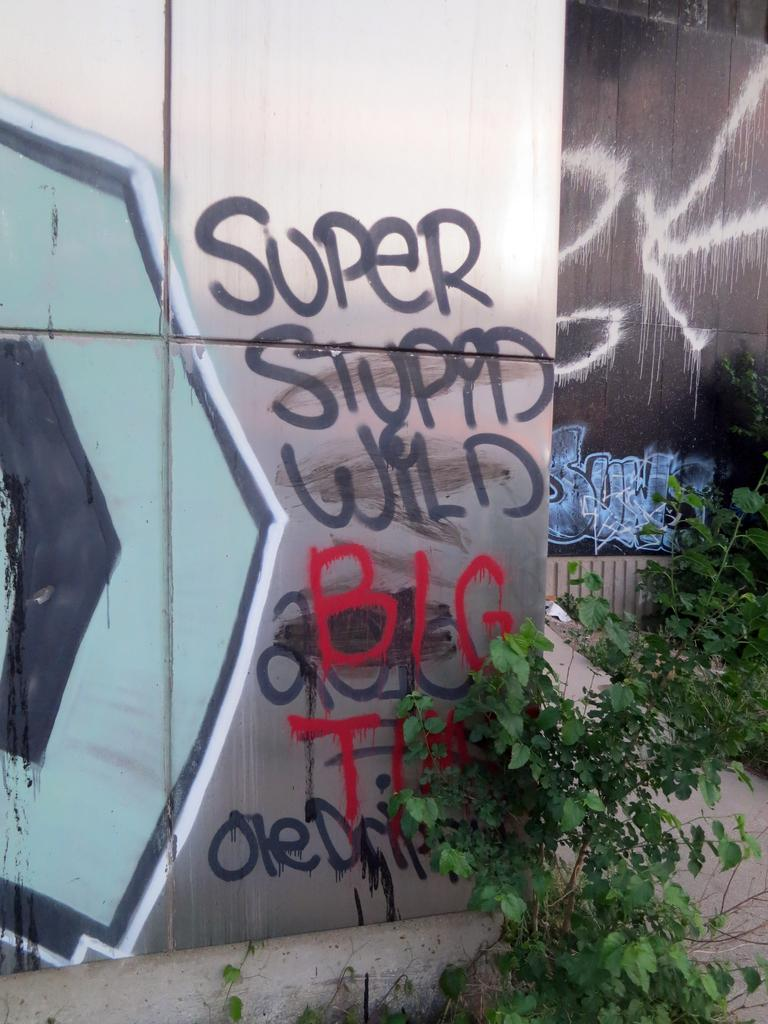What type of living organisms can be seen in the image? Plants can be seen in the image. What is featured on the walls in the image? There are walls with paintings in the image. What can be read or seen in written form in the image? There is text visible in the image. Where is the goldfish swimming in the image? There is no goldfish present in the image. What type of meeting is taking place in the image? There is no meeting depicted in the image. 